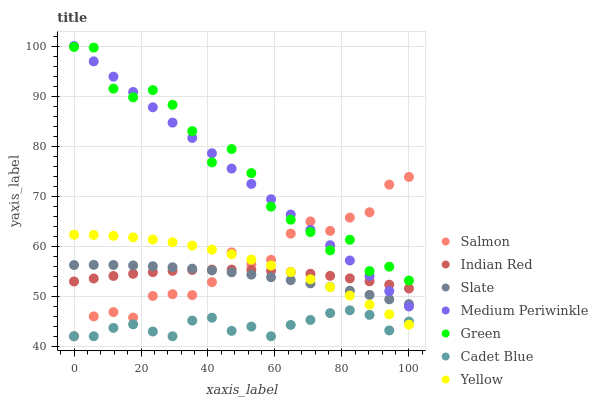Does Cadet Blue have the minimum area under the curve?
Answer yes or no. Yes. Does Green have the maximum area under the curve?
Answer yes or no. Yes. Does Salmon have the minimum area under the curve?
Answer yes or no. No. Does Salmon have the maximum area under the curve?
Answer yes or no. No. Is Medium Periwinkle the smoothest?
Answer yes or no. Yes. Is Green the roughest?
Answer yes or no. Yes. Is Salmon the smoothest?
Answer yes or no. No. Is Salmon the roughest?
Answer yes or no. No. Does Cadet Blue have the lowest value?
Answer yes or no. Yes. Does Slate have the lowest value?
Answer yes or no. No. Does Medium Periwinkle have the highest value?
Answer yes or no. Yes. Does Salmon have the highest value?
Answer yes or no. No. Is Yellow less than Medium Periwinkle?
Answer yes or no. Yes. Is Green greater than Cadet Blue?
Answer yes or no. Yes. Does Green intersect Medium Periwinkle?
Answer yes or no. Yes. Is Green less than Medium Periwinkle?
Answer yes or no. No. Is Green greater than Medium Periwinkle?
Answer yes or no. No. Does Yellow intersect Medium Periwinkle?
Answer yes or no. No. 